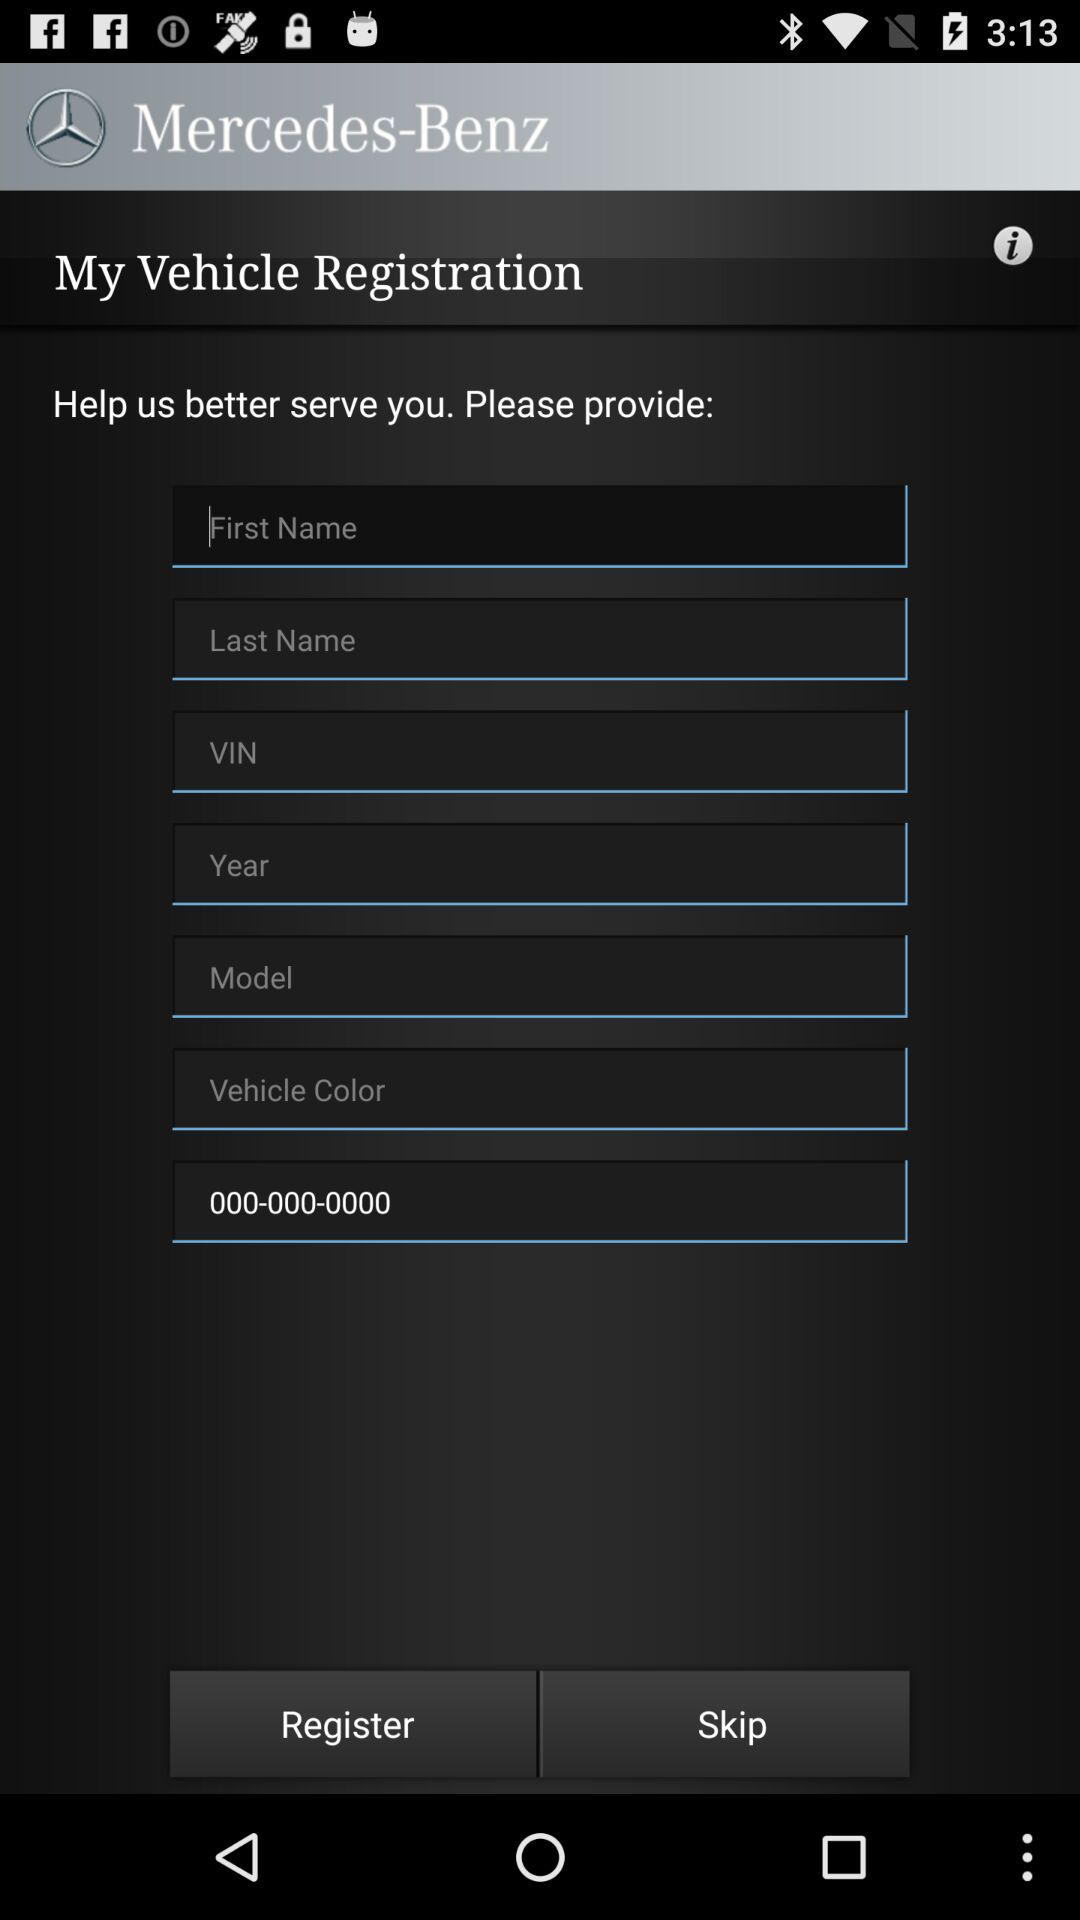How many text inputs are there that require the user to enter information?
Answer the question using a single word or phrase. 7 